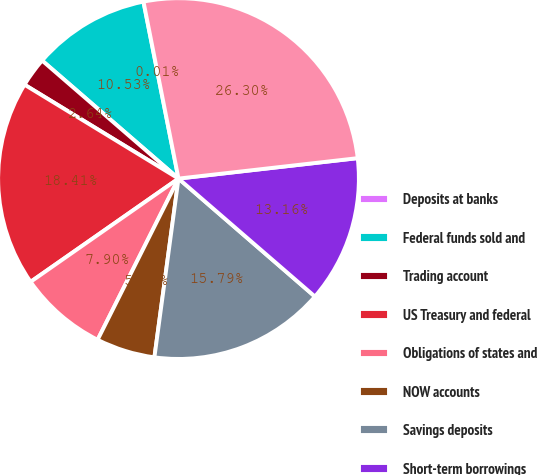Convert chart to OTSL. <chart><loc_0><loc_0><loc_500><loc_500><pie_chart><fcel>Deposits at banks<fcel>Federal funds sold and<fcel>Trading account<fcel>US Treasury and federal<fcel>Obligations of states and<fcel>NOW accounts<fcel>Savings deposits<fcel>Short-term borrowings<fcel>Long-term borrowings<nl><fcel>0.01%<fcel>10.53%<fcel>2.64%<fcel>18.42%<fcel>7.9%<fcel>5.27%<fcel>15.79%<fcel>13.16%<fcel>26.31%<nl></chart> 